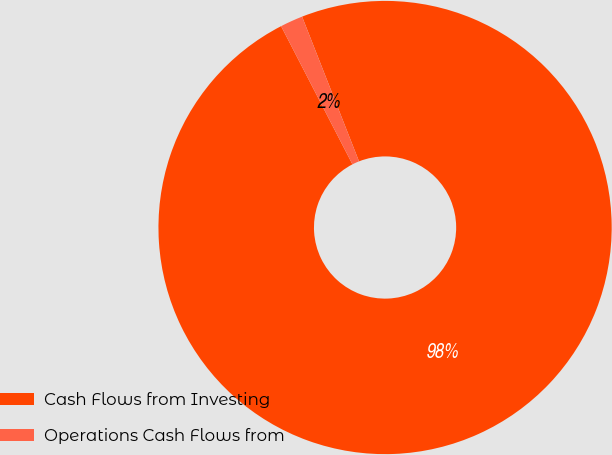Convert chart. <chart><loc_0><loc_0><loc_500><loc_500><pie_chart><fcel>Cash Flows from Investing<fcel>Operations Cash Flows from<nl><fcel>98.38%<fcel>1.62%<nl></chart> 